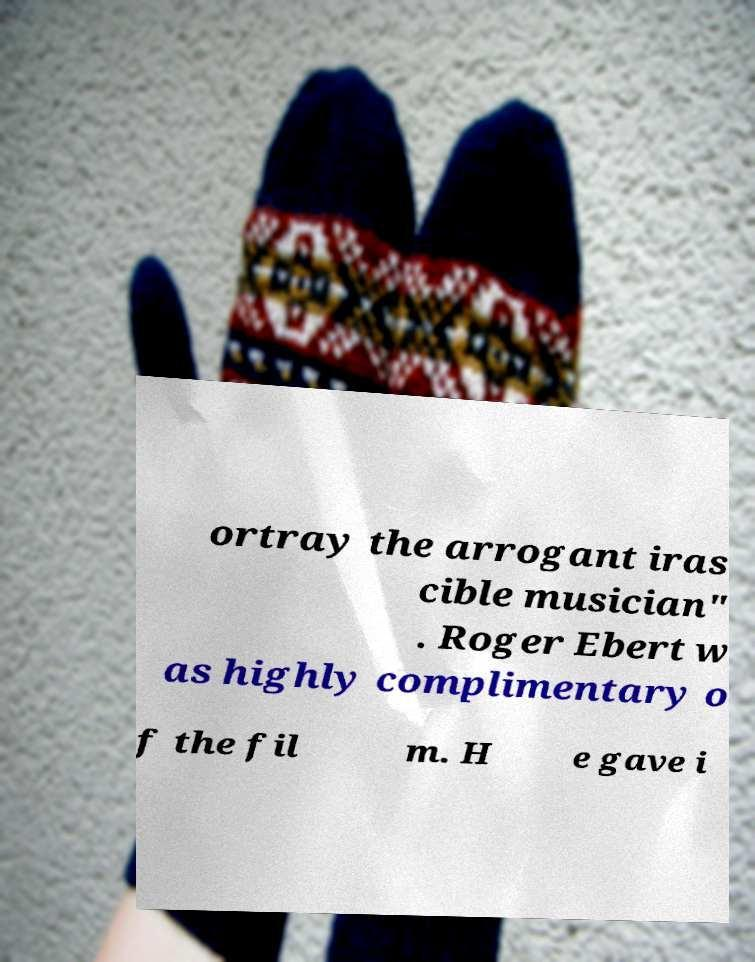Could you extract and type out the text from this image? ortray the arrogant iras cible musician" . Roger Ebert w as highly complimentary o f the fil m. H e gave i 